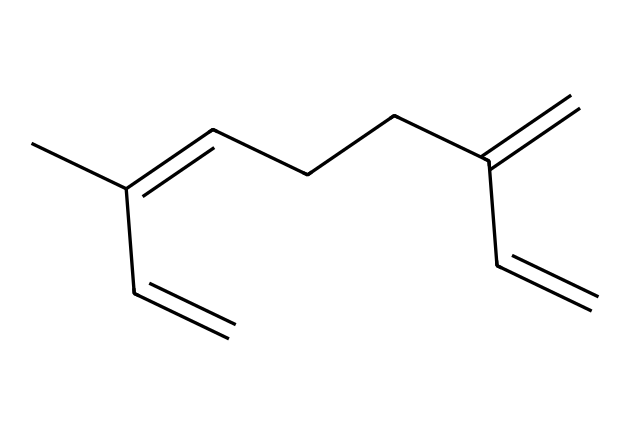What is the name of this chemical? The chemical represented by the provided SMILES structure is identified as myrcene, which is a well-known terpene. This can be determined by recognizing the distinct structural features characteristic of myrcene.
Answer: myrcene How many carbon atoms are in myrcene? To find the number of carbon atoms, we can count the "C" symbols in the SMILES notation. The structure contains 10 carbon atoms in total.
Answer: 10 What type of reaction is most likely for this terpene? Myrcene can participate in processes like cyclization, which is common for terpenes due to their multiple double bonds. The presence of these double bonds indicates reactivity and potential for cyclization reactions.
Answer: cyclization What is the main functional group present in myrcene? The primary functional groups in myrcene stem from the double bonds, specifically alkenes, as indicated by the arrangement of the carbon atoms. We can identify these double bonds in the SMILES notation.
Answer: alkenes Does myrcene have analgesic properties? Yes, research indicates that myrcene has potential analgesic effects, which can be attributed to its structure facilitating interaction with pain receptors. Available studies support its use in pain management.
Answer: yes What kind of compound is myrcene classified as? Myrcene falls under the category of terpenes, which are defined as naturally occurring compounds characterized by the formation of a distinct hydrocarbon skeleton. The structure outlined gives it this classification.
Answer: terpene 